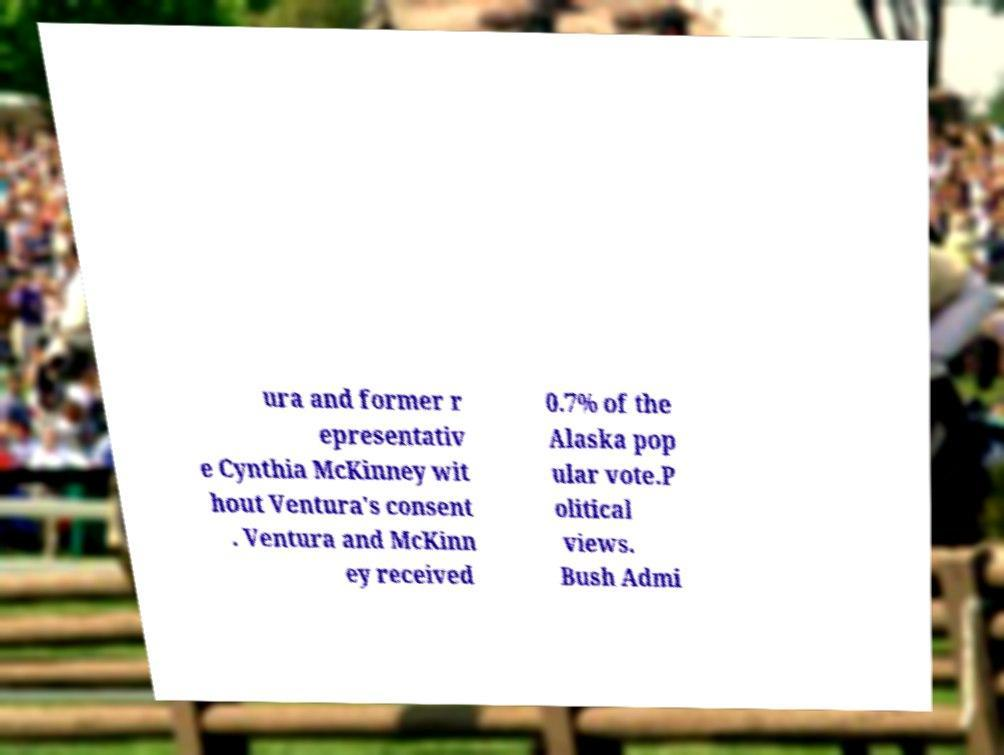Can you read and provide the text displayed in the image?This photo seems to have some interesting text. Can you extract and type it out for me? ura and former r epresentativ e Cynthia McKinney wit hout Ventura's consent . Ventura and McKinn ey received 0.7% of the Alaska pop ular vote.P olitical views. Bush Admi 